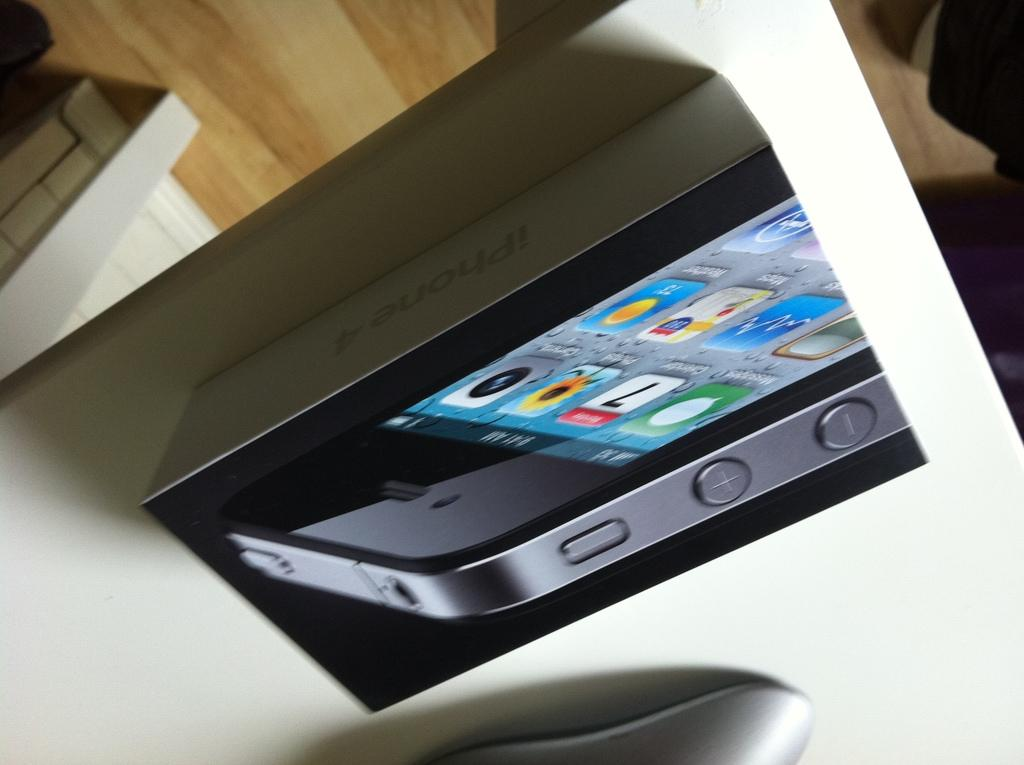Provide a one-sentence caption for the provided image. An upside down picture of an iPhone 4 box on a desk. 